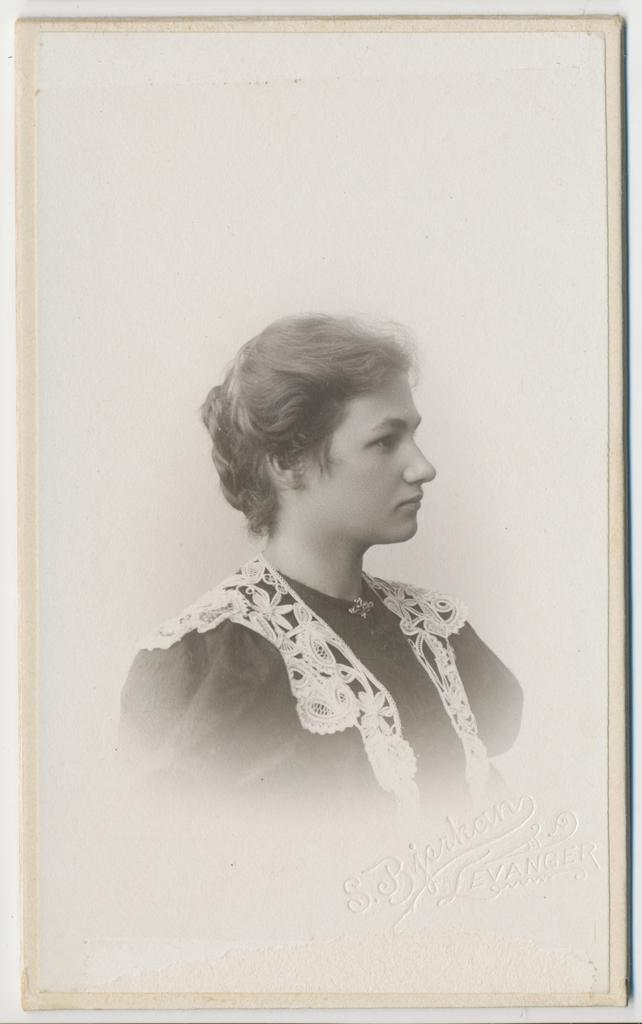What is the main subject of the image? There is a person in the image. Can you describe any additional elements in the image? There is some text in the image. What type of treatment is the person receiving in the image? There is no indication of any treatment being administered in the image; it only shows a person and some text. 